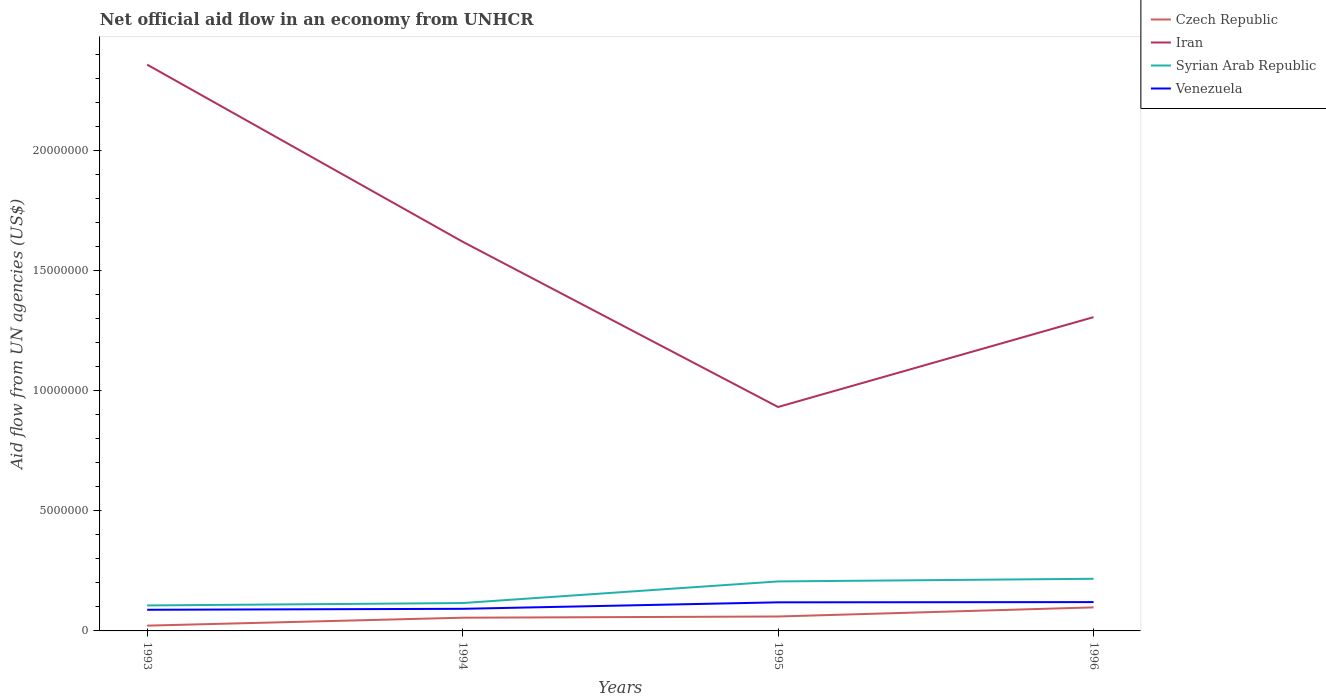How many different coloured lines are there?
Provide a short and direct response. 4. Is the number of lines equal to the number of legend labels?
Your response must be concise. Yes. Across all years, what is the maximum net official aid flow in Venezuela?
Give a very brief answer. 8.80e+05. In which year was the net official aid flow in Czech Republic maximum?
Offer a terse response. 1993. What is the total net official aid flow in Venezuela in the graph?
Make the answer very short. -3.20e+05. What is the difference between the highest and the second highest net official aid flow in Czech Republic?
Your response must be concise. 7.60e+05. What is the difference between the highest and the lowest net official aid flow in Syrian Arab Republic?
Give a very brief answer. 2. What is the difference between two consecutive major ticks on the Y-axis?
Keep it short and to the point. 5.00e+06. Does the graph contain any zero values?
Make the answer very short. No. Does the graph contain grids?
Give a very brief answer. No. How are the legend labels stacked?
Provide a succinct answer. Vertical. What is the title of the graph?
Your answer should be very brief. Net official aid flow in an economy from UNHCR. What is the label or title of the Y-axis?
Give a very brief answer. Aid flow from UN agencies (US$). What is the Aid flow from UN agencies (US$) in Iran in 1993?
Ensure brevity in your answer.  2.36e+07. What is the Aid flow from UN agencies (US$) of Syrian Arab Republic in 1993?
Your response must be concise. 1.06e+06. What is the Aid flow from UN agencies (US$) in Venezuela in 1993?
Your answer should be very brief. 8.80e+05. What is the Aid flow from UN agencies (US$) of Czech Republic in 1994?
Give a very brief answer. 5.50e+05. What is the Aid flow from UN agencies (US$) in Iran in 1994?
Keep it short and to the point. 1.62e+07. What is the Aid flow from UN agencies (US$) in Syrian Arab Republic in 1994?
Your response must be concise. 1.16e+06. What is the Aid flow from UN agencies (US$) in Venezuela in 1994?
Provide a short and direct response. 9.20e+05. What is the Aid flow from UN agencies (US$) of Iran in 1995?
Your answer should be very brief. 9.32e+06. What is the Aid flow from UN agencies (US$) in Syrian Arab Republic in 1995?
Your answer should be very brief. 2.06e+06. What is the Aid flow from UN agencies (US$) in Venezuela in 1995?
Your response must be concise. 1.19e+06. What is the Aid flow from UN agencies (US$) of Czech Republic in 1996?
Your response must be concise. 9.80e+05. What is the Aid flow from UN agencies (US$) of Iran in 1996?
Give a very brief answer. 1.31e+07. What is the Aid flow from UN agencies (US$) in Syrian Arab Republic in 1996?
Offer a terse response. 2.17e+06. What is the Aid flow from UN agencies (US$) of Venezuela in 1996?
Your answer should be very brief. 1.20e+06. Across all years, what is the maximum Aid flow from UN agencies (US$) in Czech Republic?
Offer a very short reply. 9.80e+05. Across all years, what is the maximum Aid flow from UN agencies (US$) in Iran?
Your answer should be very brief. 2.36e+07. Across all years, what is the maximum Aid flow from UN agencies (US$) in Syrian Arab Republic?
Make the answer very short. 2.17e+06. Across all years, what is the maximum Aid flow from UN agencies (US$) in Venezuela?
Provide a short and direct response. 1.20e+06. Across all years, what is the minimum Aid flow from UN agencies (US$) in Czech Republic?
Ensure brevity in your answer.  2.20e+05. Across all years, what is the minimum Aid flow from UN agencies (US$) in Iran?
Offer a very short reply. 9.32e+06. Across all years, what is the minimum Aid flow from UN agencies (US$) of Syrian Arab Republic?
Your answer should be very brief. 1.06e+06. Across all years, what is the minimum Aid flow from UN agencies (US$) of Venezuela?
Provide a succinct answer. 8.80e+05. What is the total Aid flow from UN agencies (US$) in Czech Republic in the graph?
Your answer should be very brief. 2.35e+06. What is the total Aid flow from UN agencies (US$) of Iran in the graph?
Provide a succinct answer. 6.22e+07. What is the total Aid flow from UN agencies (US$) of Syrian Arab Republic in the graph?
Your response must be concise. 6.45e+06. What is the total Aid flow from UN agencies (US$) of Venezuela in the graph?
Provide a succinct answer. 4.19e+06. What is the difference between the Aid flow from UN agencies (US$) in Czech Republic in 1993 and that in 1994?
Your answer should be compact. -3.30e+05. What is the difference between the Aid flow from UN agencies (US$) in Iran in 1993 and that in 1994?
Your response must be concise. 7.37e+06. What is the difference between the Aid flow from UN agencies (US$) of Venezuela in 1993 and that in 1994?
Make the answer very short. -4.00e+04. What is the difference between the Aid flow from UN agencies (US$) of Czech Republic in 1993 and that in 1995?
Give a very brief answer. -3.80e+05. What is the difference between the Aid flow from UN agencies (US$) in Iran in 1993 and that in 1995?
Keep it short and to the point. 1.42e+07. What is the difference between the Aid flow from UN agencies (US$) of Syrian Arab Republic in 1993 and that in 1995?
Your answer should be very brief. -1.00e+06. What is the difference between the Aid flow from UN agencies (US$) of Venezuela in 1993 and that in 1995?
Keep it short and to the point. -3.10e+05. What is the difference between the Aid flow from UN agencies (US$) of Czech Republic in 1993 and that in 1996?
Offer a very short reply. -7.60e+05. What is the difference between the Aid flow from UN agencies (US$) of Iran in 1993 and that in 1996?
Provide a succinct answer. 1.05e+07. What is the difference between the Aid flow from UN agencies (US$) of Syrian Arab Republic in 1993 and that in 1996?
Offer a very short reply. -1.11e+06. What is the difference between the Aid flow from UN agencies (US$) of Venezuela in 1993 and that in 1996?
Provide a short and direct response. -3.20e+05. What is the difference between the Aid flow from UN agencies (US$) in Czech Republic in 1994 and that in 1995?
Offer a very short reply. -5.00e+04. What is the difference between the Aid flow from UN agencies (US$) in Iran in 1994 and that in 1995?
Make the answer very short. 6.88e+06. What is the difference between the Aid flow from UN agencies (US$) in Syrian Arab Republic in 1994 and that in 1995?
Keep it short and to the point. -9.00e+05. What is the difference between the Aid flow from UN agencies (US$) in Venezuela in 1994 and that in 1995?
Your response must be concise. -2.70e+05. What is the difference between the Aid flow from UN agencies (US$) of Czech Republic in 1994 and that in 1996?
Offer a very short reply. -4.30e+05. What is the difference between the Aid flow from UN agencies (US$) in Iran in 1994 and that in 1996?
Your response must be concise. 3.14e+06. What is the difference between the Aid flow from UN agencies (US$) of Syrian Arab Republic in 1994 and that in 1996?
Offer a terse response. -1.01e+06. What is the difference between the Aid flow from UN agencies (US$) in Venezuela in 1994 and that in 1996?
Give a very brief answer. -2.80e+05. What is the difference between the Aid flow from UN agencies (US$) of Czech Republic in 1995 and that in 1996?
Ensure brevity in your answer.  -3.80e+05. What is the difference between the Aid flow from UN agencies (US$) of Iran in 1995 and that in 1996?
Keep it short and to the point. -3.74e+06. What is the difference between the Aid flow from UN agencies (US$) in Syrian Arab Republic in 1995 and that in 1996?
Make the answer very short. -1.10e+05. What is the difference between the Aid flow from UN agencies (US$) of Czech Republic in 1993 and the Aid flow from UN agencies (US$) of Iran in 1994?
Offer a very short reply. -1.60e+07. What is the difference between the Aid flow from UN agencies (US$) in Czech Republic in 1993 and the Aid flow from UN agencies (US$) in Syrian Arab Republic in 1994?
Your answer should be compact. -9.40e+05. What is the difference between the Aid flow from UN agencies (US$) in Czech Republic in 1993 and the Aid flow from UN agencies (US$) in Venezuela in 1994?
Your answer should be very brief. -7.00e+05. What is the difference between the Aid flow from UN agencies (US$) of Iran in 1993 and the Aid flow from UN agencies (US$) of Syrian Arab Republic in 1994?
Make the answer very short. 2.24e+07. What is the difference between the Aid flow from UN agencies (US$) of Iran in 1993 and the Aid flow from UN agencies (US$) of Venezuela in 1994?
Make the answer very short. 2.26e+07. What is the difference between the Aid flow from UN agencies (US$) in Czech Republic in 1993 and the Aid flow from UN agencies (US$) in Iran in 1995?
Give a very brief answer. -9.10e+06. What is the difference between the Aid flow from UN agencies (US$) in Czech Republic in 1993 and the Aid flow from UN agencies (US$) in Syrian Arab Republic in 1995?
Your answer should be very brief. -1.84e+06. What is the difference between the Aid flow from UN agencies (US$) in Czech Republic in 1993 and the Aid flow from UN agencies (US$) in Venezuela in 1995?
Make the answer very short. -9.70e+05. What is the difference between the Aid flow from UN agencies (US$) of Iran in 1993 and the Aid flow from UN agencies (US$) of Syrian Arab Republic in 1995?
Provide a short and direct response. 2.15e+07. What is the difference between the Aid flow from UN agencies (US$) in Iran in 1993 and the Aid flow from UN agencies (US$) in Venezuela in 1995?
Ensure brevity in your answer.  2.24e+07. What is the difference between the Aid flow from UN agencies (US$) of Czech Republic in 1993 and the Aid flow from UN agencies (US$) of Iran in 1996?
Provide a succinct answer. -1.28e+07. What is the difference between the Aid flow from UN agencies (US$) in Czech Republic in 1993 and the Aid flow from UN agencies (US$) in Syrian Arab Republic in 1996?
Keep it short and to the point. -1.95e+06. What is the difference between the Aid flow from UN agencies (US$) in Czech Republic in 1993 and the Aid flow from UN agencies (US$) in Venezuela in 1996?
Offer a terse response. -9.80e+05. What is the difference between the Aid flow from UN agencies (US$) of Iran in 1993 and the Aid flow from UN agencies (US$) of Syrian Arab Republic in 1996?
Ensure brevity in your answer.  2.14e+07. What is the difference between the Aid flow from UN agencies (US$) in Iran in 1993 and the Aid flow from UN agencies (US$) in Venezuela in 1996?
Your response must be concise. 2.24e+07. What is the difference between the Aid flow from UN agencies (US$) of Czech Republic in 1994 and the Aid flow from UN agencies (US$) of Iran in 1995?
Your response must be concise. -8.77e+06. What is the difference between the Aid flow from UN agencies (US$) of Czech Republic in 1994 and the Aid flow from UN agencies (US$) of Syrian Arab Republic in 1995?
Keep it short and to the point. -1.51e+06. What is the difference between the Aid flow from UN agencies (US$) of Czech Republic in 1994 and the Aid flow from UN agencies (US$) of Venezuela in 1995?
Make the answer very short. -6.40e+05. What is the difference between the Aid flow from UN agencies (US$) of Iran in 1994 and the Aid flow from UN agencies (US$) of Syrian Arab Republic in 1995?
Make the answer very short. 1.41e+07. What is the difference between the Aid flow from UN agencies (US$) in Iran in 1994 and the Aid flow from UN agencies (US$) in Venezuela in 1995?
Your response must be concise. 1.50e+07. What is the difference between the Aid flow from UN agencies (US$) of Syrian Arab Republic in 1994 and the Aid flow from UN agencies (US$) of Venezuela in 1995?
Your answer should be very brief. -3.00e+04. What is the difference between the Aid flow from UN agencies (US$) in Czech Republic in 1994 and the Aid flow from UN agencies (US$) in Iran in 1996?
Provide a succinct answer. -1.25e+07. What is the difference between the Aid flow from UN agencies (US$) of Czech Republic in 1994 and the Aid flow from UN agencies (US$) of Syrian Arab Republic in 1996?
Your response must be concise. -1.62e+06. What is the difference between the Aid flow from UN agencies (US$) of Czech Republic in 1994 and the Aid flow from UN agencies (US$) of Venezuela in 1996?
Give a very brief answer. -6.50e+05. What is the difference between the Aid flow from UN agencies (US$) in Iran in 1994 and the Aid flow from UN agencies (US$) in Syrian Arab Republic in 1996?
Your answer should be compact. 1.40e+07. What is the difference between the Aid flow from UN agencies (US$) of Iran in 1994 and the Aid flow from UN agencies (US$) of Venezuela in 1996?
Give a very brief answer. 1.50e+07. What is the difference between the Aid flow from UN agencies (US$) of Czech Republic in 1995 and the Aid flow from UN agencies (US$) of Iran in 1996?
Provide a short and direct response. -1.25e+07. What is the difference between the Aid flow from UN agencies (US$) of Czech Republic in 1995 and the Aid flow from UN agencies (US$) of Syrian Arab Republic in 1996?
Your answer should be compact. -1.57e+06. What is the difference between the Aid flow from UN agencies (US$) in Czech Republic in 1995 and the Aid flow from UN agencies (US$) in Venezuela in 1996?
Give a very brief answer. -6.00e+05. What is the difference between the Aid flow from UN agencies (US$) in Iran in 1995 and the Aid flow from UN agencies (US$) in Syrian Arab Republic in 1996?
Your answer should be very brief. 7.15e+06. What is the difference between the Aid flow from UN agencies (US$) of Iran in 1995 and the Aid flow from UN agencies (US$) of Venezuela in 1996?
Ensure brevity in your answer.  8.12e+06. What is the difference between the Aid flow from UN agencies (US$) of Syrian Arab Republic in 1995 and the Aid flow from UN agencies (US$) of Venezuela in 1996?
Your response must be concise. 8.60e+05. What is the average Aid flow from UN agencies (US$) of Czech Republic per year?
Keep it short and to the point. 5.88e+05. What is the average Aid flow from UN agencies (US$) in Iran per year?
Offer a very short reply. 1.55e+07. What is the average Aid flow from UN agencies (US$) of Syrian Arab Republic per year?
Ensure brevity in your answer.  1.61e+06. What is the average Aid flow from UN agencies (US$) in Venezuela per year?
Keep it short and to the point. 1.05e+06. In the year 1993, what is the difference between the Aid flow from UN agencies (US$) of Czech Republic and Aid flow from UN agencies (US$) of Iran?
Ensure brevity in your answer.  -2.34e+07. In the year 1993, what is the difference between the Aid flow from UN agencies (US$) in Czech Republic and Aid flow from UN agencies (US$) in Syrian Arab Republic?
Offer a very short reply. -8.40e+05. In the year 1993, what is the difference between the Aid flow from UN agencies (US$) of Czech Republic and Aid flow from UN agencies (US$) of Venezuela?
Keep it short and to the point. -6.60e+05. In the year 1993, what is the difference between the Aid flow from UN agencies (US$) of Iran and Aid flow from UN agencies (US$) of Syrian Arab Republic?
Offer a terse response. 2.25e+07. In the year 1993, what is the difference between the Aid flow from UN agencies (US$) of Iran and Aid flow from UN agencies (US$) of Venezuela?
Provide a succinct answer. 2.27e+07. In the year 1993, what is the difference between the Aid flow from UN agencies (US$) of Syrian Arab Republic and Aid flow from UN agencies (US$) of Venezuela?
Make the answer very short. 1.80e+05. In the year 1994, what is the difference between the Aid flow from UN agencies (US$) in Czech Republic and Aid flow from UN agencies (US$) in Iran?
Your answer should be very brief. -1.56e+07. In the year 1994, what is the difference between the Aid flow from UN agencies (US$) of Czech Republic and Aid flow from UN agencies (US$) of Syrian Arab Republic?
Keep it short and to the point. -6.10e+05. In the year 1994, what is the difference between the Aid flow from UN agencies (US$) of Czech Republic and Aid flow from UN agencies (US$) of Venezuela?
Give a very brief answer. -3.70e+05. In the year 1994, what is the difference between the Aid flow from UN agencies (US$) of Iran and Aid flow from UN agencies (US$) of Syrian Arab Republic?
Ensure brevity in your answer.  1.50e+07. In the year 1994, what is the difference between the Aid flow from UN agencies (US$) in Iran and Aid flow from UN agencies (US$) in Venezuela?
Your response must be concise. 1.53e+07. In the year 1994, what is the difference between the Aid flow from UN agencies (US$) in Syrian Arab Republic and Aid flow from UN agencies (US$) in Venezuela?
Ensure brevity in your answer.  2.40e+05. In the year 1995, what is the difference between the Aid flow from UN agencies (US$) in Czech Republic and Aid flow from UN agencies (US$) in Iran?
Your response must be concise. -8.72e+06. In the year 1995, what is the difference between the Aid flow from UN agencies (US$) in Czech Republic and Aid flow from UN agencies (US$) in Syrian Arab Republic?
Offer a terse response. -1.46e+06. In the year 1995, what is the difference between the Aid flow from UN agencies (US$) of Czech Republic and Aid flow from UN agencies (US$) of Venezuela?
Your response must be concise. -5.90e+05. In the year 1995, what is the difference between the Aid flow from UN agencies (US$) in Iran and Aid flow from UN agencies (US$) in Syrian Arab Republic?
Your response must be concise. 7.26e+06. In the year 1995, what is the difference between the Aid flow from UN agencies (US$) in Iran and Aid flow from UN agencies (US$) in Venezuela?
Make the answer very short. 8.13e+06. In the year 1995, what is the difference between the Aid flow from UN agencies (US$) in Syrian Arab Republic and Aid flow from UN agencies (US$) in Venezuela?
Give a very brief answer. 8.70e+05. In the year 1996, what is the difference between the Aid flow from UN agencies (US$) of Czech Republic and Aid flow from UN agencies (US$) of Iran?
Provide a succinct answer. -1.21e+07. In the year 1996, what is the difference between the Aid flow from UN agencies (US$) of Czech Republic and Aid flow from UN agencies (US$) of Syrian Arab Republic?
Give a very brief answer. -1.19e+06. In the year 1996, what is the difference between the Aid flow from UN agencies (US$) of Iran and Aid flow from UN agencies (US$) of Syrian Arab Republic?
Your answer should be very brief. 1.09e+07. In the year 1996, what is the difference between the Aid flow from UN agencies (US$) in Iran and Aid flow from UN agencies (US$) in Venezuela?
Your answer should be compact. 1.19e+07. In the year 1996, what is the difference between the Aid flow from UN agencies (US$) of Syrian Arab Republic and Aid flow from UN agencies (US$) of Venezuela?
Your response must be concise. 9.70e+05. What is the ratio of the Aid flow from UN agencies (US$) in Iran in 1993 to that in 1994?
Your response must be concise. 1.45. What is the ratio of the Aid flow from UN agencies (US$) of Syrian Arab Republic in 1993 to that in 1994?
Make the answer very short. 0.91. What is the ratio of the Aid flow from UN agencies (US$) in Venezuela in 1993 to that in 1994?
Ensure brevity in your answer.  0.96. What is the ratio of the Aid flow from UN agencies (US$) in Czech Republic in 1993 to that in 1995?
Offer a very short reply. 0.37. What is the ratio of the Aid flow from UN agencies (US$) in Iran in 1993 to that in 1995?
Provide a succinct answer. 2.53. What is the ratio of the Aid flow from UN agencies (US$) in Syrian Arab Republic in 1993 to that in 1995?
Provide a short and direct response. 0.51. What is the ratio of the Aid flow from UN agencies (US$) of Venezuela in 1993 to that in 1995?
Make the answer very short. 0.74. What is the ratio of the Aid flow from UN agencies (US$) in Czech Republic in 1993 to that in 1996?
Give a very brief answer. 0.22. What is the ratio of the Aid flow from UN agencies (US$) of Iran in 1993 to that in 1996?
Provide a short and direct response. 1.8. What is the ratio of the Aid flow from UN agencies (US$) of Syrian Arab Republic in 1993 to that in 1996?
Offer a very short reply. 0.49. What is the ratio of the Aid flow from UN agencies (US$) of Venezuela in 1993 to that in 1996?
Make the answer very short. 0.73. What is the ratio of the Aid flow from UN agencies (US$) of Czech Republic in 1994 to that in 1995?
Offer a terse response. 0.92. What is the ratio of the Aid flow from UN agencies (US$) in Iran in 1994 to that in 1995?
Your answer should be very brief. 1.74. What is the ratio of the Aid flow from UN agencies (US$) of Syrian Arab Republic in 1994 to that in 1995?
Ensure brevity in your answer.  0.56. What is the ratio of the Aid flow from UN agencies (US$) in Venezuela in 1994 to that in 1995?
Provide a short and direct response. 0.77. What is the ratio of the Aid flow from UN agencies (US$) in Czech Republic in 1994 to that in 1996?
Your response must be concise. 0.56. What is the ratio of the Aid flow from UN agencies (US$) in Iran in 1994 to that in 1996?
Provide a succinct answer. 1.24. What is the ratio of the Aid flow from UN agencies (US$) in Syrian Arab Republic in 1994 to that in 1996?
Your answer should be very brief. 0.53. What is the ratio of the Aid flow from UN agencies (US$) in Venezuela in 1994 to that in 1996?
Give a very brief answer. 0.77. What is the ratio of the Aid flow from UN agencies (US$) in Czech Republic in 1995 to that in 1996?
Provide a short and direct response. 0.61. What is the ratio of the Aid flow from UN agencies (US$) in Iran in 1995 to that in 1996?
Give a very brief answer. 0.71. What is the ratio of the Aid flow from UN agencies (US$) in Syrian Arab Republic in 1995 to that in 1996?
Offer a terse response. 0.95. What is the difference between the highest and the second highest Aid flow from UN agencies (US$) of Czech Republic?
Your answer should be compact. 3.80e+05. What is the difference between the highest and the second highest Aid flow from UN agencies (US$) in Iran?
Your answer should be compact. 7.37e+06. What is the difference between the highest and the second highest Aid flow from UN agencies (US$) in Venezuela?
Your response must be concise. 10000. What is the difference between the highest and the lowest Aid flow from UN agencies (US$) in Czech Republic?
Provide a succinct answer. 7.60e+05. What is the difference between the highest and the lowest Aid flow from UN agencies (US$) in Iran?
Keep it short and to the point. 1.42e+07. What is the difference between the highest and the lowest Aid flow from UN agencies (US$) of Syrian Arab Republic?
Your answer should be very brief. 1.11e+06. What is the difference between the highest and the lowest Aid flow from UN agencies (US$) in Venezuela?
Your response must be concise. 3.20e+05. 